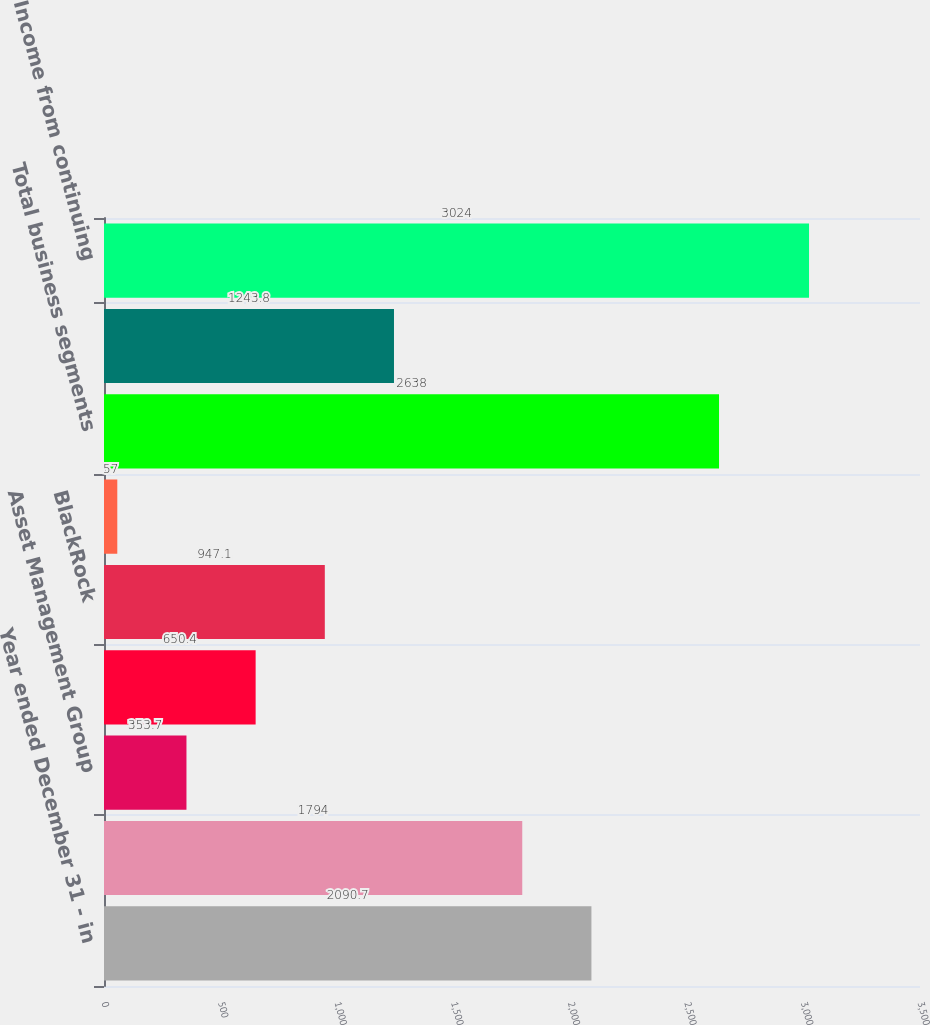Convert chart to OTSL. <chart><loc_0><loc_0><loc_500><loc_500><bar_chart><fcel>Year ended December 31 - in<fcel>Corporate & Institutional<fcel>Asset Management Group<fcel>Residential Mortgage Banking<fcel>BlackRock<fcel>Non-Strategic Assets Portfolio<fcel>Total business segments<fcel>Other (b) (c)<fcel>Income from continuing<nl><fcel>2090.7<fcel>1794<fcel>353.7<fcel>650.4<fcel>947.1<fcel>57<fcel>2638<fcel>1243.8<fcel>3024<nl></chart> 